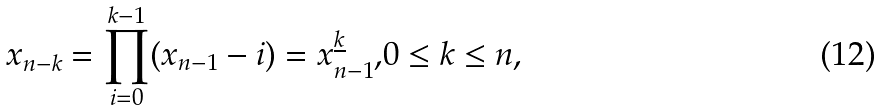Convert formula to latex. <formula><loc_0><loc_0><loc_500><loc_500>x _ { n - k } = \prod _ { i = 0 } ^ { k - 1 } ( x _ { n - 1 } - i ) = x _ { n - 1 } ^ { \underline { k } } \text  , 0 \leq k \leq n\text  ,</formula> 